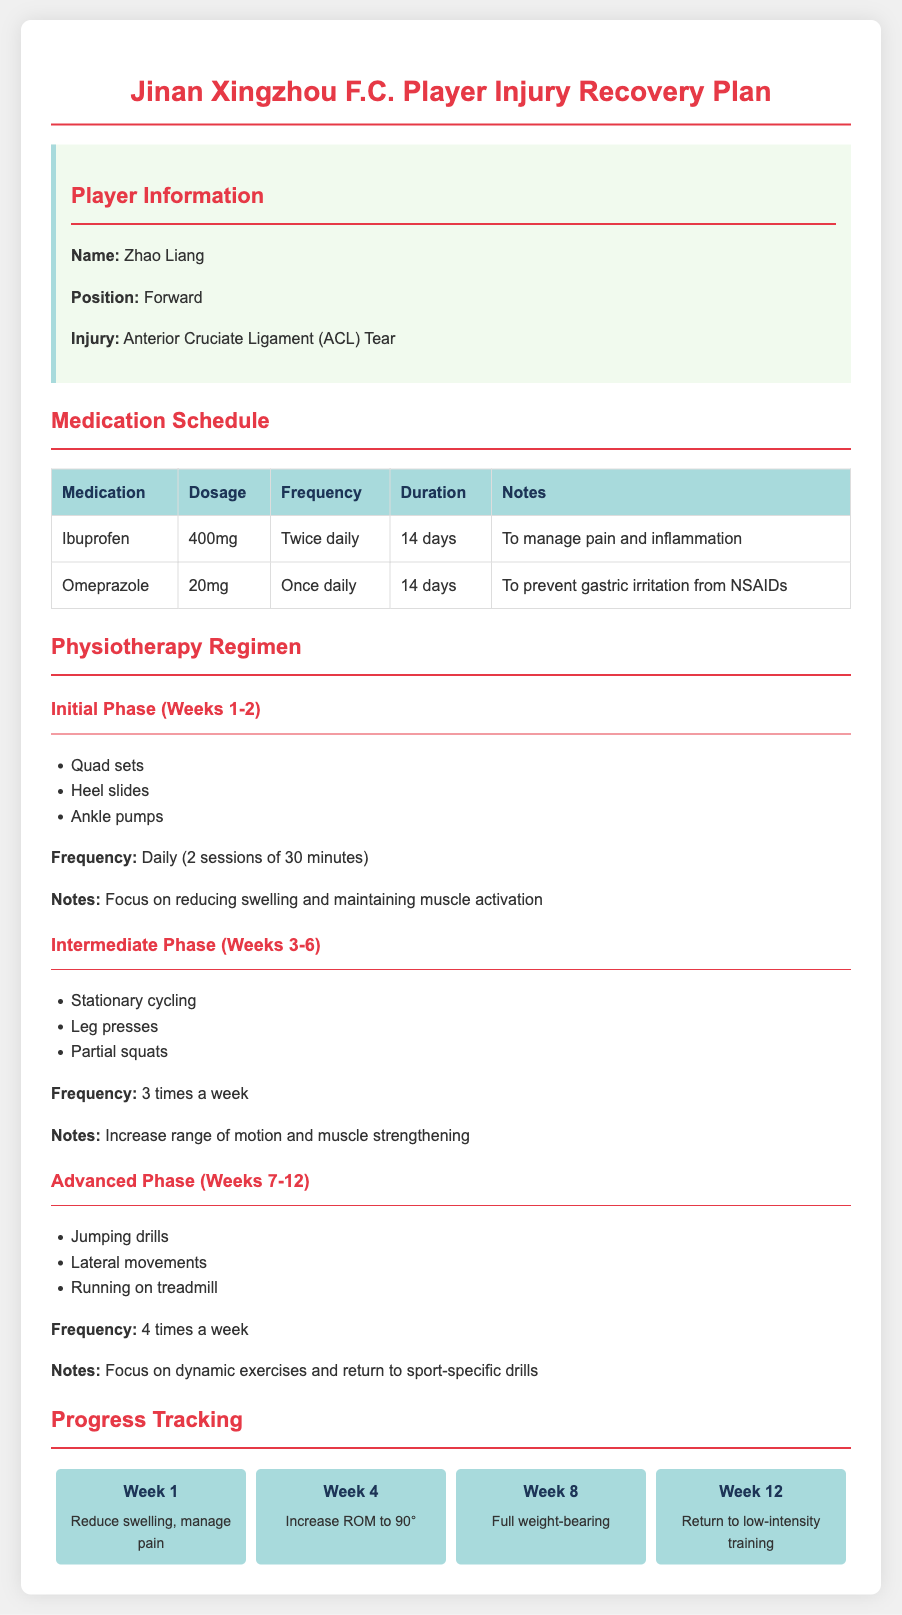What is the player's name? The player's name is clearly stated in the document.
Answer: Zhao Liang What is the injury sustained by the player? The injury type is specified under the "Player Information" section.
Answer: Anterior Cruciate Ligament (ACL) Tear How long is the Ibuprofen dosage prescribed for? The duration for the medication is mentioned in the "Medication Schedule" table.
Answer: 14 days What is the recommended frequency for stationary cycling? The frequency for this exercise is found in the "Intermediate Phase" section of the document.
Answer: 3 times a week What is the main goal of the Initial Phase in physiotherapy? The goal is summarized in the notes of the Initial Phase section.
Answer: Reducing swelling and maintaining muscle activation What should be achieved by Week 4 in the recovery plan? The expected progress is noted in the "Progress Tracking" section.
Answer: Increase ROM to 90° In which phase are jumping drills included? The specific phase is stated under the "Advanced Phase" section.
Answer: Advanced Phase What is the dosage for Omeprazole? The specific dosage information is provided in the "Medication Schedule" table.
Answer: 20mg How many sessions are recommended in the Initial Phase? The number of sessions is indicated in the Initial Phase description.
Answer: 2 sessions of 30 minutes 